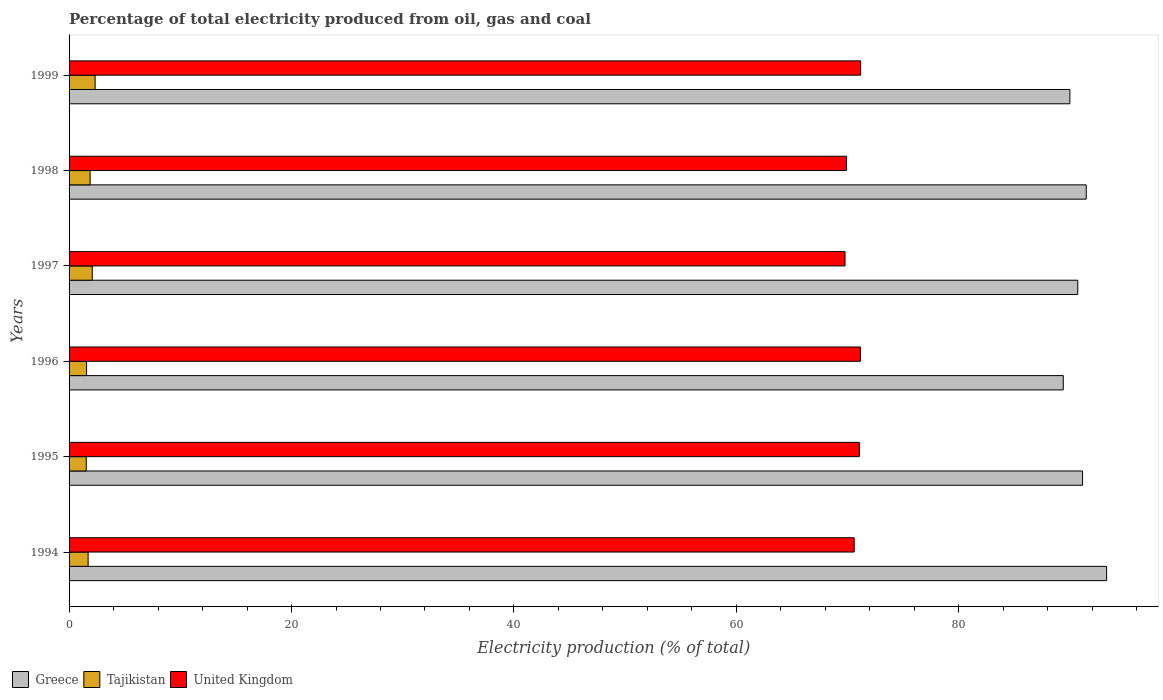How many groups of bars are there?
Keep it short and to the point. 6. Are the number of bars on each tick of the Y-axis equal?
Your response must be concise. Yes. In how many cases, is the number of bars for a given year not equal to the number of legend labels?
Give a very brief answer. 0. What is the electricity production in in Greece in 1997?
Give a very brief answer. 90.69. Across all years, what is the maximum electricity production in in United Kingdom?
Offer a terse response. 71.17. Across all years, what is the minimum electricity production in in United Kingdom?
Offer a very short reply. 69.76. In which year was the electricity production in in Tajikistan maximum?
Ensure brevity in your answer.  1999. What is the total electricity production in in Tajikistan in the graph?
Provide a short and direct response. 11.15. What is the difference between the electricity production in in Greece in 1994 and that in 1996?
Offer a terse response. 3.9. What is the difference between the electricity production in in United Kingdom in 1994 and the electricity production in in Tajikistan in 1997?
Your answer should be compact. 68.51. What is the average electricity production in in United Kingdom per year?
Your response must be concise. 70.6. In the year 1996, what is the difference between the electricity production in in Tajikistan and electricity production in in Greece?
Your answer should be compact. -87.81. In how many years, is the electricity production in in United Kingdom greater than 84 %?
Provide a succinct answer. 0. What is the ratio of the electricity production in in Greece in 1995 to that in 1999?
Ensure brevity in your answer.  1.01. Is the electricity production in in Tajikistan in 1994 less than that in 1997?
Ensure brevity in your answer.  Yes. What is the difference between the highest and the second highest electricity production in in Tajikistan?
Give a very brief answer. 0.26. What is the difference between the highest and the lowest electricity production in in United Kingdom?
Make the answer very short. 1.4. What does the 1st bar from the top in 1994 represents?
Make the answer very short. United Kingdom. How many bars are there?
Provide a succinct answer. 18. How many years are there in the graph?
Ensure brevity in your answer.  6. What is the difference between two consecutive major ticks on the X-axis?
Your answer should be very brief. 20. Does the graph contain grids?
Offer a terse response. No. Where does the legend appear in the graph?
Offer a very short reply. Bottom left. How many legend labels are there?
Make the answer very short. 3. What is the title of the graph?
Offer a very short reply. Percentage of total electricity produced from oil, gas and coal. Does "Mauritius" appear as one of the legend labels in the graph?
Your response must be concise. No. What is the label or title of the X-axis?
Your answer should be compact. Electricity production (% of total). What is the Electricity production (% of total) of Greece in 1994?
Ensure brevity in your answer.  93.28. What is the Electricity production (% of total) of Tajikistan in 1994?
Offer a terse response. 1.71. What is the Electricity production (% of total) in United Kingdom in 1994?
Provide a succinct answer. 70.59. What is the Electricity production (% of total) in Greece in 1995?
Provide a succinct answer. 91.12. What is the Electricity production (% of total) in Tajikistan in 1995?
Your answer should be very brief. 1.54. What is the Electricity production (% of total) in United Kingdom in 1995?
Your answer should be compact. 71.05. What is the Electricity production (% of total) in Greece in 1996?
Provide a succinct answer. 89.39. What is the Electricity production (% of total) of Tajikistan in 1996?
Provide a short and direct response. 1.57. What is the Electricity production (% of total) of United Kingdom in 1996?
Offer a terse response. 71.15. What is the Electricity production (% of total) of Greece in 1997?
Provide a short and direct response. 90.69. What is the Electricity production (% of total) in Tajikistan in 1997?
Give a very brief answer. 2.08. What is the Electricity production (% of total) in United Kingdom in 1997?
Give a very brief answer. 69.76. What is the Electricity production (% of total) of Greece in 1998?
Your answer should be very brief. 91.45. What is the Electricity production (% of total) in Tajikistan in 1998?
Give a very brief answer. 1.89. What is the Electricity production (% of total) of United Kingdom in 1998?
Make the answer very short. 69.89. What is the Electricity production (% of total) of Greece in 1999?
Provide a succinct answer. 89.98. What is the Electricity production (% of total) of Tajikistan in 1999?
Give a very brief answer. 2.34. What is the Electricity production (% of total) of United Kingdom in 1999?
Your response must be concise. 71.17. Across all years, what is the maximum Electricity production (% of total) in Greece?
Your answer should be very brief. 93.28. Across all years, what is the maximum Electricity production (% of total) of Tajikistan?
Ensure brevity in your answer.  2.34. Across all years, what is the maximum Electricity production (% of total) of United Kingdom?
Ensure brevity in your answer.  71.17. Across all years, what is the minimum Electricity production (% of total) of Greece?
Ensure brevity in your answer.  89.39. Across all years, what is the minimum Electricity production (% of total) in Tajikistan?
Your answer should be very brief. 1.54. Across all years, what is the minimum Electricity production (% of total) of United Kingdom?
Make the answer very short. 69.76. What is the total Electricity production (% of total) of Greece in the graph?
Ensure brevity in your answer.  545.91. What is the total Electricity production (% of total) of Tajikistan in the graph?
Give a very brief answer. 11.15. What is the total Electricity production (% of total) of United Kingdom in the graph?
Provide a short and direct response. 423.62. What is the difference between the Electricity production (% of total) of Greece in 1994 and that in 1995?
Offer a very short reply. 2.16. What is the difference between the Electricity production (% of total) of Tajikistan in 1994 and that in 1995?
Ensure brevity in your answer.  0.17. What is the difference between the Electricity production (% of total) in United Kingdom in 1994 and that in 1995?
Keep it short and to the point. -0.46. What is the difference between the Electricity production (% of total) of Greece in 1994 and that in 1996?
Offer a terse response. 3.9. What is the difference between the Electricity production (% of total) of Tajikistan in 1994 and that in 1996?
Your answer should be very brief. 0.14. What is the difference between the Electricity production (% of total) in United Kingdom in 1994 and that in 1996?
Offer a terse response. -0.56. What is the difference between the Electricity production (% of total) in Greece in 1994 and that in 1997?
Offer a terse response. 2.6. What is the difference between the Electricity production (% of total) in Tajikistan in 1994 and that in 1997?
Keep it short and to the point. -0.37. What is the difference between the Electricity production (% of total) in United Kingdom in 1994 and that in 1997?
Ensure brevity in your answer.  0.83. What is the difference between the Electricity production (% of total) of Greece in 1994 and that in 1998?
Provide a succinct answer. 1.83. What is the difference between the Electricity production (% of total) in Tajikistan in 1994 and that in 1998?
Make the answer very short. -0.18. What is the difference between the Electricity production (% of total) of United Kingdom in 1994 and that in 1998?
Your response must be concise. 0.7. What is the difference between the Electricity production (% of total) of Greece in 1994 and that in 1999?
Offer a very short reply. 3.31. What is the difference between the Electricity production (% of total) in Tajikistan in 1994 and that in 1999?
Your answer should be very brief. -0.63. What is the difference between the Electricity production (% of total) of United Kingdom in 1994 and that in 1999?
Your answer should be compact. -0.58. What is the difference between the Electricity production (% of total) of Greece in 1995 and that in 1996?
Make the answer very short. 1.73. What is the difference between the Electricity production (% of total) of Tajikistan in 1995 and that in 1996?
Provide a succinct answer. -0.03. What is the difference between the Electricity production (% of total) in United Kingdom in 1995 and that in 1996?
Give a very brief answer. -0.1. What is the difference between the Electricity production (% of total) of Greece in 1995 and that in 1997?
Offer a terse response. 0.43. What is the difference between the Electricity production (% of total) in Tajikistan in 1995 and that in 1997?
Your answer should be very brief. -0.54. What is the difference between the Electricity production (% of total) of United Kingdom in 1995 and that in 1997?
Ensure brevity in your answer.  1.29. What is the difference between the Electricity production (% of total) in Greece in 1995 and that in 1998?
Your response must be concise. -0.33. What is the difference between the Electricity production (% of total) in Tajikistan in 1995 and that in 1998?
Your response must be concise. -0.35. What is the difference between the Electricity production (% of total) of United Kingdom in 1995 and that in 1998?
Your answer should be compact. 1.16. What is the difference between the Electricity production (% of total) of Greece in 1995 and that in 1999?
Offer a terse response. 1.14. What is the difference between the Electricity production (% of total) of Tajikistan in 1995 and that in 1999?
Your answer should be compact. -0.8. What is the difference between the Electricity production (% of total) of United Kingdom in 1995 and that in 1999?
Offer a very short reply. -0.12. What is the difference between the Electricity production (% of total) in Greece in 1996 and that in 1997?
Your response must be concise. -1.3. What is the difference between the Electricity production (% of total) in Tajikistan in 1996 and that in 1997?
Provide a succinct answer. -0.51. What is the difference between the Electricity production (% of total) of United Kingdom in 1996 and that in 1997?
Your response must be concise. 1.39. What is the difference between the Electricity production (% of total) in Greece in 1996 and that in 1998?
Offer a very short reply. -2.07. What is the difference between the Electricity production (% of total) of Tajikistan in 1996 and that in 1998?
Your answer should be very brief. -0.32. What is the difference between the Electricity production (% of total) in United Kingdom in 1996 and that in 1998?
Keep it short and to the point. 1.26. What is the difference between the Electricity production (% of total) in Greece in 1996 and that in 1999?
Offer a terse response. -0.59. What is the difference between the Electricity production (% of total) in Tajikistan in 1996 and that in 1999?
Provide a short and direct response. -0.77. What is the difference between the Electricity production (% of total) of United Kingdom in 1996 and that in 1999?
Offer a terse response. -0.02. What is the difference between the Electricity production (% of total) of Greece in 1997 and that in 1998?
Offer a very short reply. -0.76. What is the difference between the Electricity production (% of total) in Tajikistan in 1997 and that in 1998?
Offer a terse response. 0.19. What is the difference between the Electricity production (% of total) of United Kingdom in 1997 and that in 1998?
Provide a succinct answer. -0.13. What is the difference between the Electricity production (% of total) in Greece in 1997 and that in 1999?
Provide a short and direct response. 0.71. What is the difference between the Electricity production (% of total) in Tajikistan in 1997 and that in 1999?
Ensure brevity in your answer.  -0.26. What is the difference between the Electricity production (% of total) in United Kingdom in 1997 and that in 1999?
Offer a very short reply. -1.4. What is the difference between the Electricity production (% of total) of Greece in 1998 and that in 1999?
Your answer should be very brief. 1.47. What is the difference between the Electricity production (% of total) of Tajikistan in 1998 and that in 1999?
Ensure brevity in your answer.  -0.45. What is the difference between the Electricity production (% of total) in United Kingdom in 1998 and that in 1999?
Offer a terse response. -1.28. What is the difference between the Electricity production (% of total) in Greece in 1994 and the Electricity production (% of total) in Tajikistan in 1995?
Offer a terse response. 91.74. What is the difference between the Electricity production (% of total) in Greece in 1994 and the Electricity production (% of total) in United Kingdom in 1995?
Keep it short and to the point. 22.23. What is the difference between the Electricity production (% of total) of Tajikistan in 1994 and the Electricity production (% of total) of United Kingdom in 1995?
Make the answer very short. -69.34. What is the difference between the Electricity production (% of total) in Greece in 1994 and the Electricity production (% of total) in Tajikistan in 1996?
Ensure brevity in your answer.  91.71. What is the difference between the Electricity production (% of total) of Greece in 1994 and the Electricity production (% of total) of United Kingdom in 1996?
Provide a succinct answer. 22.13. What is the difference between the Electricity production (% of total) of Tajikistan in 1994 and the Electricity production (% of total) of United Kingdom in 1996?
Provide a succinct answer. -69.44. What is the difference between the Electricity production (% of total) in Greece in 1994 and the Electricity production (% of total) in Tajikistan in 1997?
Ensure brevity in your answer.  91.2. What is the difference between the Electricity production (% of total) in Greece in 1994 and the Electricity production (% of total) in United Kingdom in 1997?
Provide a short and direct response. 23.52. What is the difference between the Electricity production (% of total) of Tajikistan in 1994 and the Electricity production (% of total) of United Kingdom in 1997?
Your answer should be very brief. -68.05. What is the difference between the Electricity production (% of total) of Greece in 1994 and the Electricity production (% of total) of Tajikistan in 1998?
Offer a very short reply. 91.39. What is the difference between the Electricity production (% of total) of Greece in 1994 and the Electricity production (% of total) of United Kingdom in 1998?
Your answer should be compact. 23.39. What is the difference between the Electricity production (% of total) in Tajikistan in 1994 and the Electricity production (% of total) in United Kingdom in 1998?
Your answer should be very brief. -68.18. What is the difference between the Electricity production (% of total) of Greece in 1994 and the Electricity production (% of total) of Tajikistan in 1999?
Offer a very short reply. 90.94. What is the difference between the Electricity production (% of total) of Greece in 1994 and the Electricity production (% of total) of United Kingdom in 1999?
Offer a terse response. 22.12. What is the difference between the Electricity production (% of total) in Tajikistan in 1994 and the Electricity production (% of total) in United Kingdom in 1999?
Keep it short and to the point. -69.45. What is the difference between the Electricity production (% of total) of Greece in 1995 and the Electricity production (% of total) of Tajikistan in 1996?
Provide a succinct answer. 89.55. What is the difference between the Electricity production (% of total) in Greece in 1995 and the Electricity production (% of total) in United Kingdom in 1996?
Your answer should be very brief. 19.97. What is the difference between the Electricity production (% of total) in Tajikistan in 1995 and the Electricity production (% of total) in United Kingdom in 1996?
Your answer should be very brief. -69.61. What is the difference between the Electricity production (% of total) of Greece in 1995 and the Electricity production (% of total) of Tajikistan in 1997?
Your response must be concise. 89.04. What is the difference between the Electricity production (% of total) of Greece in 1995 and the Electricity production (% of total) of United Kingdom in 1997?
Keep it short and to the point. 21.36. What is the difference between the Electricity production (% of total) of Tajikistan in 1995 and the Electricity production (% of total) of United Kingdom in 1997?
Offer a very short reply. -68.22. What is the difference between the Electricity production (% of total) in Greece in 1995 and the Electricity production (% of total) in Tajikistan in 1998?
Give a very brief answer. 89.23. What is the difference between the Electricity production (% of total) in Greece in 1995 and the Electricity production (% of total) in United Kingdom in 1998?
Make the answer very short. 21.23. What is the difference between the Electricity production (% of total) in Tajikistan in 1995 and the Electricity production (% of total) in United Kingdom in 1998?
Provide a short and direct response. -68.35. What is the difference between the Electricity production (% of total) in Greece in 1995 and the Electricity production (% of total) in Tajikistan in 1999?
Give a very brief answer. 88.78. What is the difference between the Electricity production (% of total) in Greece in 1995 and the Electricity production (% of total) in United Kingdom in 1999?
Your response must be concise. 19.95. What is the difference between the Electricity production (% of total) of Tajikistan in 1995 and the Electricity production (% of total) of United Kingdom in 1999?
Provide a succinct answer. -69.62. What is the difference between the Electricity production (% of total) of Greece in 1996 and the Electricity production (% of total) of Tajikistan in 1997?
Provide a succinct answer. 87.3. What is the difference between the Electricity production (% of total) in Greece in 1996 and the Electricity production (% of total) in United Kingdom in 1997?
Give a very brief answer. 19.62. What is the difference between the Electricity production (% of total) in Tajikistan in 1996 and the Electricity production (% of total) in United Kingdom in 1997?
Make the answer very short. -68.19. What is the difference between the Electricity production (% of total) of Greece in 1996 and the Electricity production (% of total) of Tajikistan in 1998?
Your answer should be compact. 87.49. What is the difference between the Electricity production (% of total) of Greece in 1996 and the Electricity production (% of total) of United Kingdom in 1998?
Offer a terse response. 19.5. What is the difference between the Electricity production (% of total) of Tajikistan in 1996 and the Electricity production (% of total) of United Kingdom in 1998?
Provide a short and direct response. -68.32. What is the difference between the Electricity production (% of total) in Greece in 1996 and the Electricity production (% of total) in Tajikistan in 1999?
Your response must be concise. 87.05. What is the difference between the Electricity production (% of total) of Greece in 1996 and the Electricity production (% of total) of United Kingdom in 1999?
Keep it short and to the point. 18.22. What is the difference between the Electricity production (% of total) in Tajikistan in 1996 and the Electricity production (% of total) in United Kingdom in 1999?
Offer a terse response. -69.59. What is the difference between the Electricity production (% of total) of Greece in 1997 and the Electricity production (% of total) of Tajikistan in 1998?
Give a very brief answer. 88.8. What is the difference between the Electricity production (% of total) of Greece in 1997 and the Electricity production (% of total) of United Kingdom in 1998?
Your response must be concise. 20.8. What is the difference between the Electricity production (% of total) in Tajikistan in 1997 and the Electricity production (% of total) in United Kingdom in 1998?
Your response must be concise. -67.81. What is the difference between the Electricity production (% of total) of Greece in 1997 and the Electricity production (% of total) of Tajikistan in 1999?
Provide a short and direct response. 88.35. What is the difference between the Electricity production (% of total) in Greece in 1997 and the Electricity production (% of total) in United Kingdom in 1999?
Provide a short and direct response. 19.52. What is the difference between the Electricity production (% of total) of Tajikistan in 1997 and the Electricity production (% of total) of United Kingdom in 1999?
Make the answer very short. -69.08. What is the difference between the Electricity production (% of total) in Greece in 1998 and the Electricity production (% of total) in Tajikistan in 1999?
Your answer should be very brief. 89.11. What is the difference between the Electricity production (% of total) of Greece in 1998 and the Electricity production (% of total) of United Kingdom in 1999?
Ensure brevity in your answer.  20.28. What is the difference between the Electricity production (% of total) of Tajikistan in 1998 and the Electricity production (% of total) of United Kingdom in 1999?
Make the answer very short. -69.28. What is the average Electricity production (% of total) in Greece per year?
Offer a very short reply. 90.99. What is the average Electricity production (% of total) of Tajikistan per year?
Keep it short and to the point. 1.86. What is the average Electricity production (% of total) in United Kingdom per year?
Provide a short and direct response. 70.6. In the year 1994, what is the difference between the Electricity production (% of total) of Greece and Electricity production (% of total) of Tajikistan?
Your answer should be compact. 91.57. In the year 1994, what is the difference between the Electricity production (% of total) in Greece and Electricity production (% of total) in United Kingdom?
Offer a very short reply. 22.69. In the year 1994, what is the difference between the Electricity production (% of total) in Tajikistan and Electricity production (% of total) in United Kingdom?
Provide a succinct answer. -68.88. In the year 1995, what is the difference between the Electricity production (% of total) in Greece and Electricity production (% of total) in Tajikistan?
Provide a succinct answer. 89.58. In the year 1995, what is the difference between the Electricity production (% of total) in Greece and Electricity production (% of total) in United Kingdom?
Your response must be concise. 20.07. In the year 1995, what is the difference between the Electricity production (% of total) in Tajikistan and Electricity production (% of total) in United Kingdom?
Your answer should be compact. -69.51. In the year 1996, what is the difference between the Electricity production (% of total) in Greece and Electricity production (% of total) in Tajikistan?
Provide a succinct answer. 87.81. In the year 1996, what is the difference between the Electricity production (% of total) of Greece and Electricity production (% of total) of United Kingdom?
Offer a very short reply. 18.24. In the year 1996, what is the difference between the Electricity production (% of total) of Tajikistan and Electricity production (% of total) of United Kingdom?
Provide a succinct answer. -69.58. In the year 1997, what is the difference between the Electricity production (% of total) of Greece and Electricity production (% of total) of Tajikistan?
Make the answer very short. 88.6. In the year 1997, what is the difference between the Electricity production (% of total) in Greece and Electricity production (% of total) in United Kingdom?
Your answer should be compact. 20.92. In the year 1997, what is the difference between the Electricity production (% of total) in Tajikistan and Electricity production (% of total) in United Kingdom?
Give a very brief answer. -67.68. In the year 1998, what is the difference between the Electricity production (% of total) in Greece and Electricity production (% of total) in Tajikistan?
Keep it short and to the point. 89.56. In the year 1998, what is the difference between the Electricity production (% of total) in Greece and Electricity production (% of total) in United Kingdom?
Provide a succinct answer. 21.56. In the year 1998, what is the difference between the Electricity production (% of total) in Tajikistan and Electricity production (% of total) in United Kingdom?
Your answer should be compact. -68. In the year 1999, what is the difference between the Electricity production (% of total) of Greece and Electricity production (% of total) of Tajikistan?
Provide a succinct answer. 87.64. In the year 1999, what is the difference between the Electricity production (% of total) in Greece and Electricity production (% of total) in United Kingdom?
Provide a short and direct response. 18.81. In the year 1999, what is the difference between the Electricity production (% of total) in Tajikistan and Electricity production (% of total) in United Kingdom?
Offer a very short reply. -68.83. What is the ratio of the Electricity production (% of total) of Greece in 1994 to that in 1995?
Offer a terse response. 1.02. What is the ratio of the Electricity production (% of total) of Tajikistan in 1994 to that in 1995?
Keep it short and to the point. 1.11. What is the ratio of the Electricity production (% of total) in United Kingdom in 1994 to that in 1995?
Your answer should be compact. 0.99. What is the ratio of the Electricity production (% of total) in Greece in 1994 to that in 1996?
Ensure brevity in your answer.  1.04. What is the ratio of the Electricity production (% of total) of Tajikistan in 1994 to that in 1996?
Ensure brevity in your answer.  1.09. What is the ratio of the Electricity production (% of total) of United Kingdom in 1994 to that in 1996?
Offer a terse response. 0.99. What is the ratio of the Electricity production (% of total) in Greece in 1994 to that in 1997?
Your response must be concise. 1.03. What is the ratio of the Electricity production (% of total) of Tajikistan in 1994 to that in 1997?
Offer a terse response. 0.82. What is the ratio of the Electricity production (% of total) of United Kingdom in 1994 to that in 1997?
Ensure brevity in your answer.  1.01. What is the ratio of the Electricity production (% of total) of Greece in 1994 to that in 1998?
Make the answer very short. 1.02. What is the ratio of the Electricity production (% of total) of Tajikistan in 1994 to that in 1998?
Provide a succinct answer. 0.91. What is the ratio of the Electricity production (% of total) in Greece in 1994 to that in 1999?
Give a very brief answer. 1.04. What is the ratio of the Electricity production (% of total) of Tajikistan in 1994 to that in 1999?
Give a very brief answer. 0.73. What is the ratio of the Electricity production (% of total) in United Kingdom in 1994 to that in 1999?
Give a very brief answer. 0.99. What is the ratio of the Electricity production (% of total) in Greece in 1995 to that in 1996?
Your answer should be compact. 1.02. What is the ratio of the Electricity production (% of total) in Tajikistan in 1995 to that in 1996?
Provide a succinct answer. 0.98. What is the ratio of the Electricity production (% of total) of Greece in 1995 to that in 1997?
Your answer should be very brief. 1. What is the ratio of the Electricity production (% of total) in Tajikistan in 1995 to that in 1997?
Your answer should be compact. 0.74. What is the ratio of the Electricity production (% of total) in United Kingdom in 1995 to that in 1997?
Your answer should be very brief. 1.02. What is the ratio of the Electricity production (% of total) of Greece in 1995 to that in 1998?
Give a very brief answer. 1. What is the ratio of the Electricity production (% of total) in Tajikistan in 1995 to that in 1998?
Your answer should be very brief. 0.82. What is the ratio of the Electricity production (% of total) of United Kingdom in 1995 to that in 1998?
Keep it short and to the point. 1.02. What is the ratio of the Electricity production (% of total) of Greece in 1995 to that in 1999?
Make the answer very short. 1.01. What is the ratio of the Electricity production (% of total) of Tajikistan in 1995 to that in 1999?
Make the answer very short. 0.66. What is the ratio of the Electricity production (% of total) of United Kingdom in 1995 to that in 1999?
Make the answer very short. 1. What is the ratio of the Electricity production (% of total) of Greece in 1996 to that in 1997?
Offer a very short reply. 0.99. What is the ratio of the Electricity production (% of total) in Tajikistan in 1996 to that in 1997?
Offer a very short reply. 0.75. What is the ratio of the Electricity production (% of total) in United Kingdom in 1996 to that in 1997?
Ensure brevity in your answer.  1.02. What is the ratio of the Electricity production (% of total) of Greece in 1996 to that in 1998?
Your answer should be compact. 0.98. What is the ratio of the Electricity production (% of total) in Tajikistan in 1996 to that in 1998?
Your response must be concise. 0.83. What is the ratio of the Electricity production (% of total) of United Kingdom in 1996 to that in 1998?
Ensure brevity in your answer.  1.02. What is the ratio of the Electricity production (% of total) in Tajikistan in 1996 to that in 1999?
Ensure brevity in your answer.  0.67. What is the ratio of the Electricity production (% of total) in Greece in 1997 to that in 1998?
Keep it short and to the point. 0.99. What is the ratio of the Electricity production (% of total) of Tajikistan in 1997 to that in 1998?
Your response must be concise. 1.1. What is the ratio of the Electricity production (% of total) in Greece in 1997 to that in 1999?
Make the answer very short. 1.01. What is the ratio of the Electricity production (% of total) of Tajikistan in 1997 to that in 1999?
Your response must be concise. 0.89. What is the ratio of the Electricity production (% of total) in United Kingdom in 1997 to that in 1999?
Make the answer very short. 0.98. What is the ratio of the Electricity production (% of total) in Greece in 1998 to that in 1999?
Offer a terse response. 1.02. What is the ratio of the Electricity production (% of total) of Tajikistan in 1998 to that in 1999?
Your response must be concise. 0.81. What is the difference between the highest and the second highest Electricity production (% of total) in Greece?
Offer a very short reply. 1.83. What is the difference between the highest and the second highest Electricity production (% of total) of Tajikistan?
Give a very brief answer. 0.26. What is the difference between the highest and the second highest Electricity production (% of total) in United Kingdom?
Your answer should be compact. 0.02. What is the difference between the highest and the lowest Electricity production (% of total) of Greece?
Provide a short and direct response. 3.9. What is the difference between the highest and the lowest Electricity production (% of total) of Tajikistan?
Keep it short and to the point. 0.8. What is the difference between the highest and the lowest Electricity production (% of total) of United Kingdom?
Your answer should be compact. 1.4. 